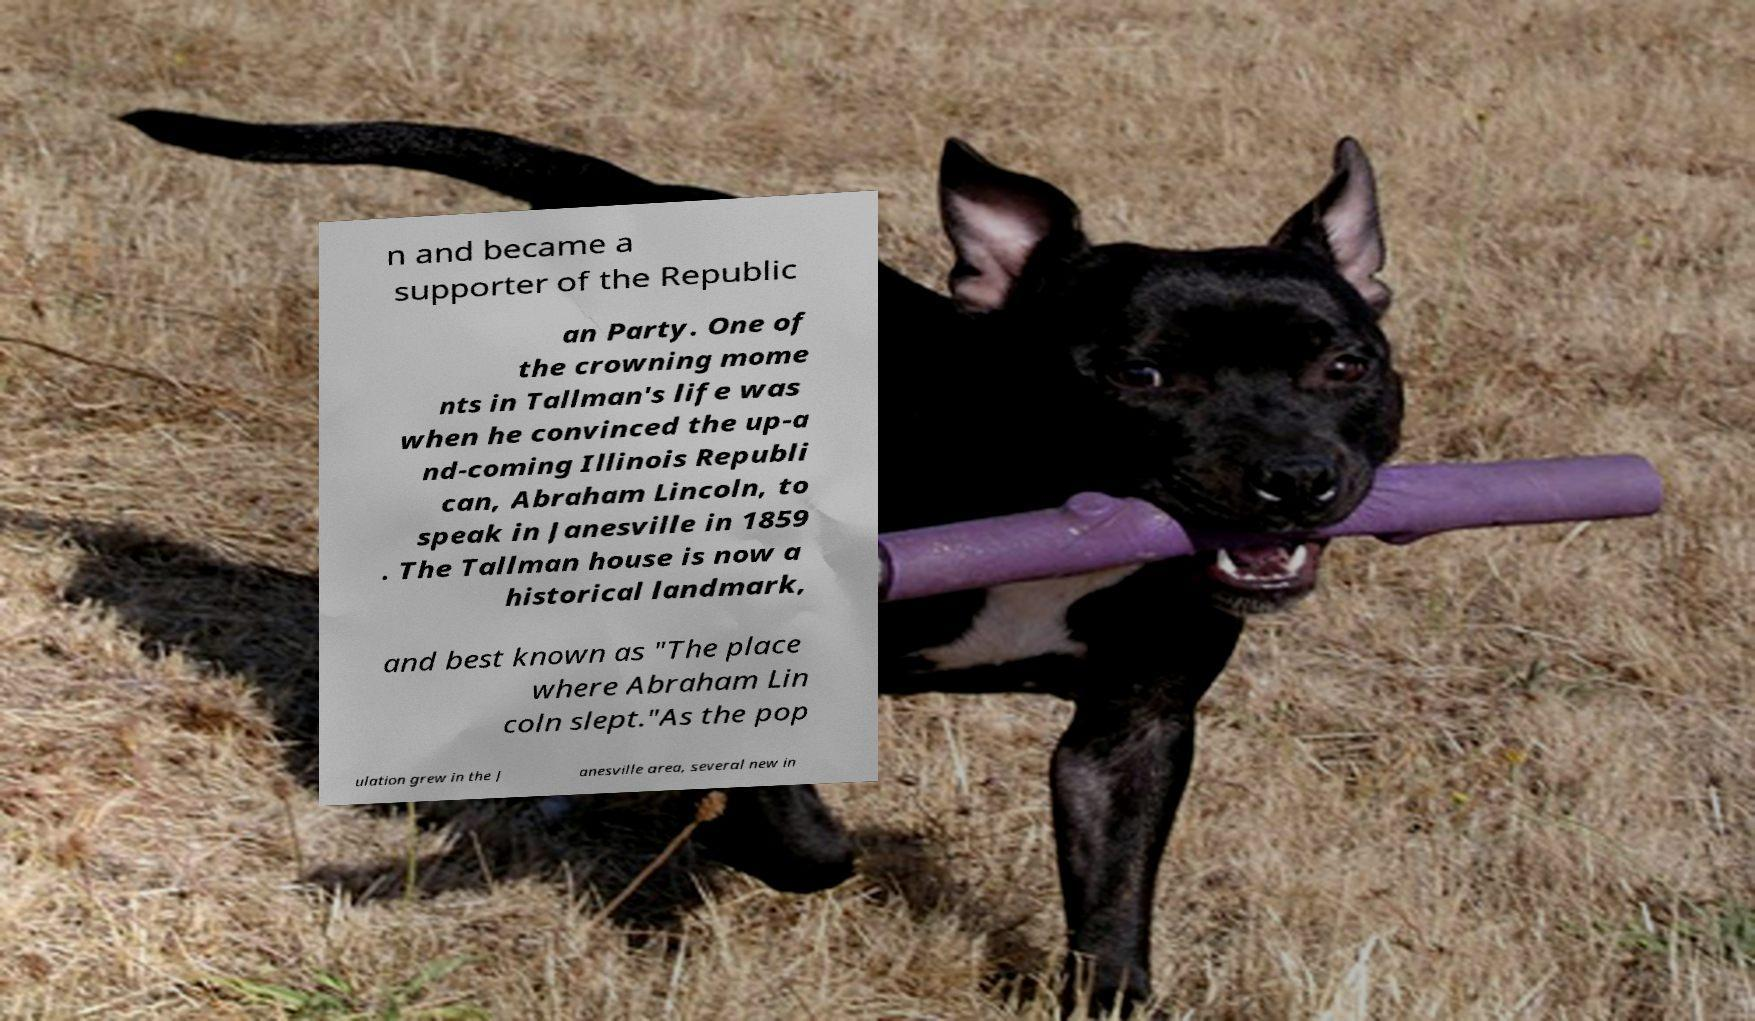There's text embedded in this image that I need extracted. Can you transcribe it verbatim? n and became a supporter of the Republic an Party. One of the crowning mome nts in Tallman's life was when he convinced the up-a nd-coming Illinois Republi can, Abraham Lincoln, to speak in Janesville in 1859 . The Tallman house is now a historical landmark, and best known as "The place where Abraham Lin coln slept."As the pop ulation grew in the J anesville area, several new in 